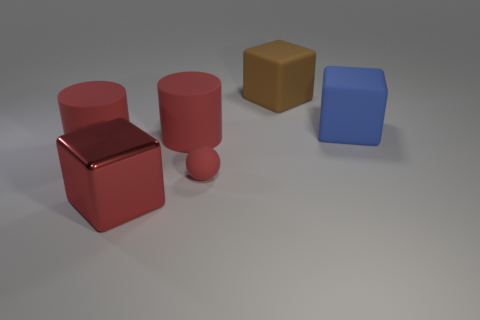The small thing is what shape?
Give a very brief answer. Sphere. What size is the shiny thing that is the same color as the sphere?
Offer a terse response. Large. Is there a large blue cube made of the same material as the small sphere?
Ensure brevity in your answer.  Yes. Is the number of blue blocks greater than the number of tiny gray cubes?
Your response must be concise. Yes. Is the material of the small object the same as the red block?
Provide a short and direct response. No. How many metallic objects are big blue cubes or small yellow cubes?
Keep it short and to the point. 0. The metallic object that is the same size as the brown rubber cube is what color?
Your answer should be compact. Red. What number of other red metal objects are the same shape as the tiny thing?
Offer a terse response. 0. What number of blocks are matte objects or small brown metallic objects?
Your answer should be compact. 2. There is a red object in front of the rubber ball; is its shape the same as the matte object that is behind the large blue rubber block?
Your answer should be very brief. Yes. 